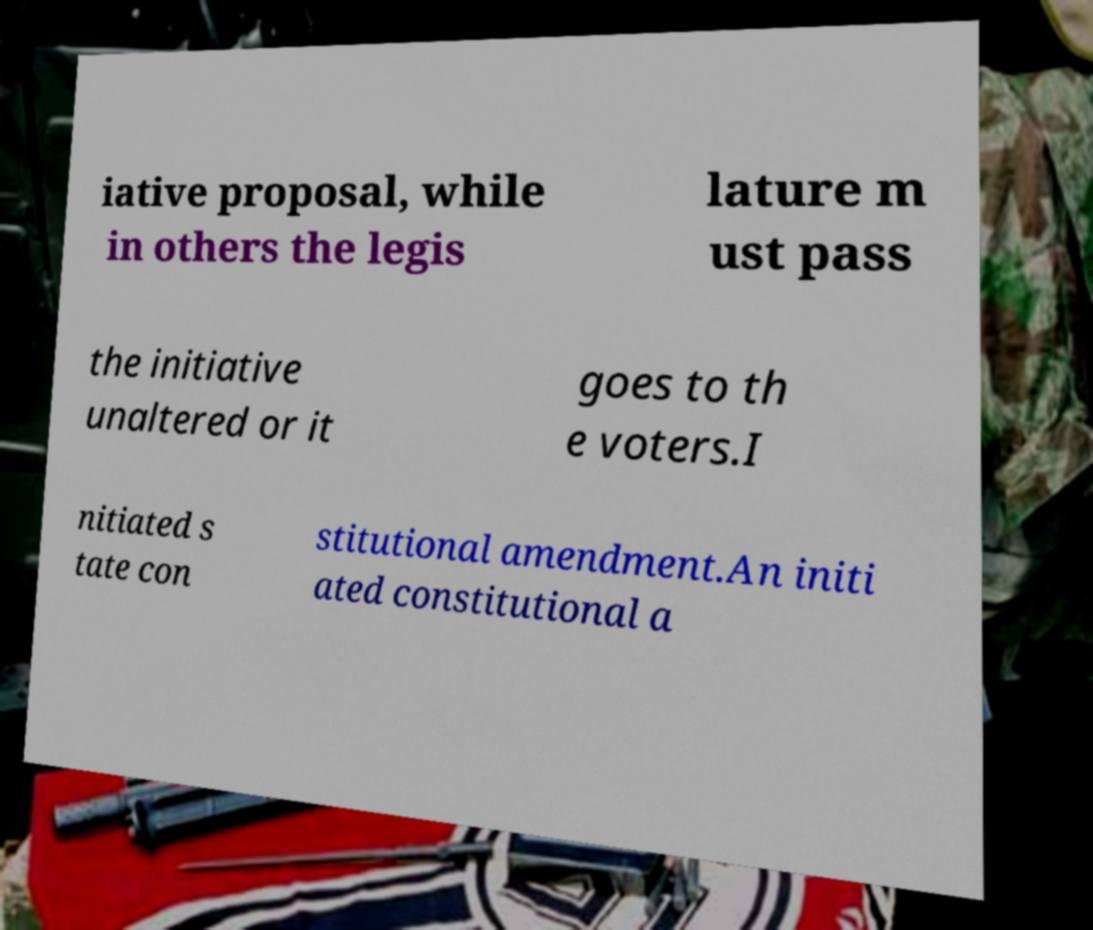Please identify and transcribe the text found in this image. iative proposal, while in others the legis lature m ust pass the initiative unaltered or it goes to th e voters.I nitiated s tate con stitutional amendment.An initi ated constitutional a 